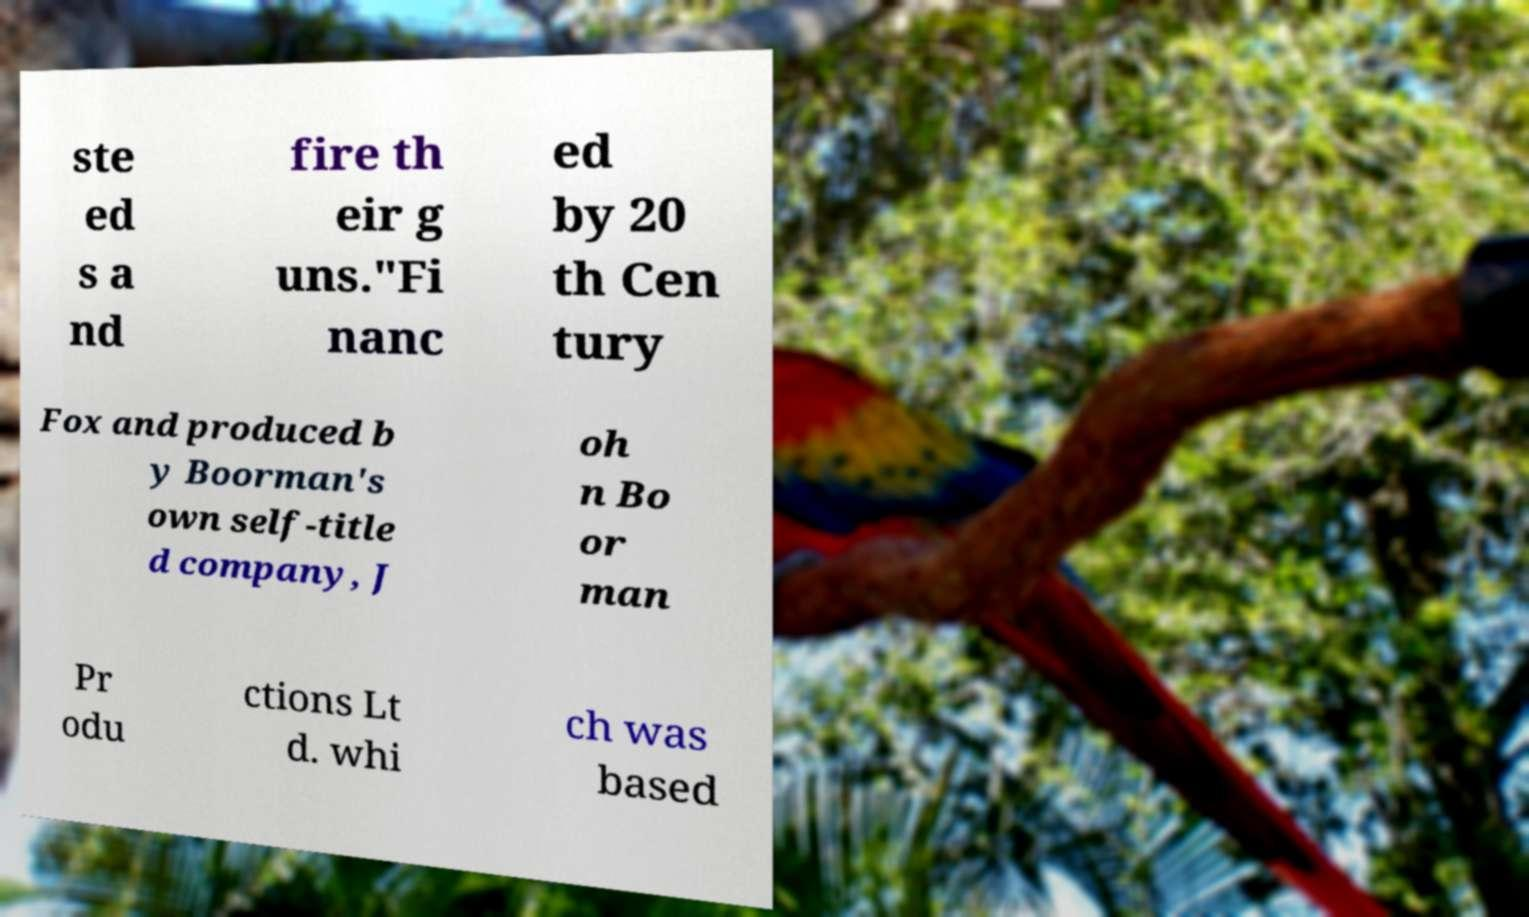Please identify and transcribe the text found in this image. ste ed s a nd fire th eir g uns."Fi nanc ed by 20 th Cen tury Fox and produced b y Boorman's own self-title d company, J oh n Bo or man Pr odu ctions Lt d. whi ch was based 